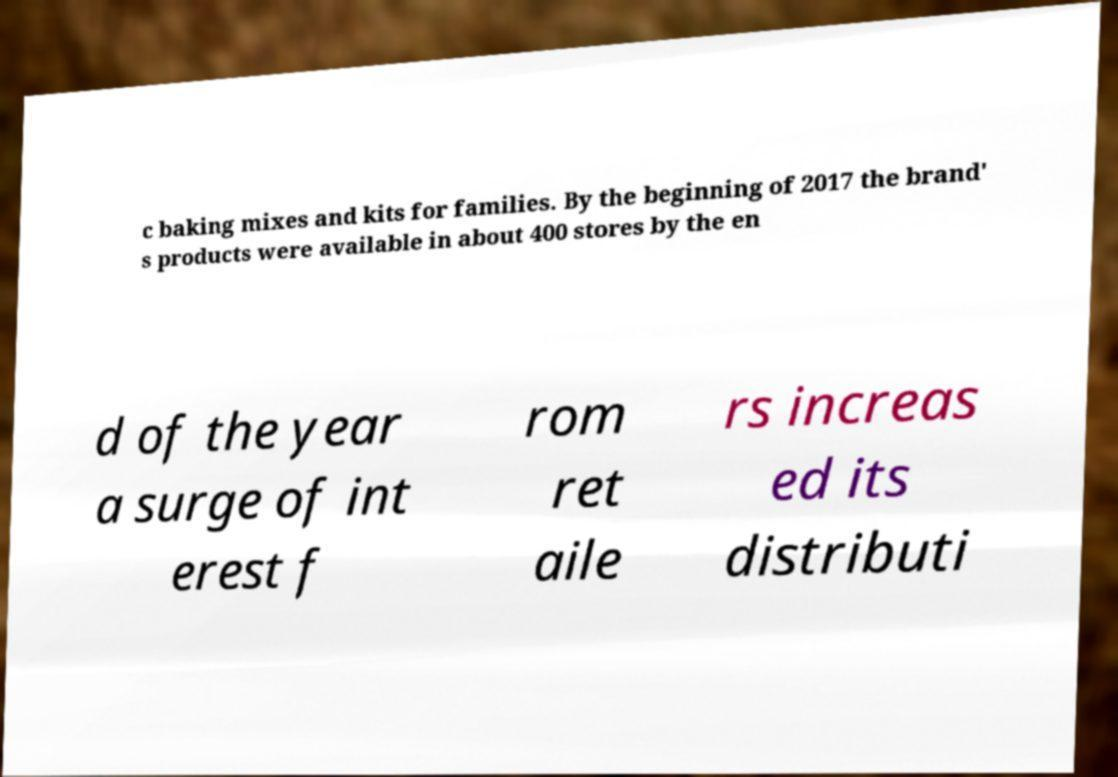Can you accurately transcribe the text from the provided image for me? c baking mixes and kits for families. By the beginning of 2017 the brand' s products were available in about 400 stores by the en d of the year a surge of int erest f rom ret aile rs increas ed its distributi 